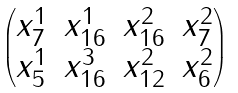<formula> <loc_0><loc_0><loc_500><loc_500>\begin{pmatrix} x _ { 7 } ^ { 1 } & x _ { 1 6 } ^ { 1 } & x _ { 1 6 } ^ { 2 } & x _ { 7 } ^ { 2 } \\ x _ { 5 } ^ { 1 } & x _ { 1 6 } ^ { 3 } & x _ { 1 2 } ^ { 2 } & x _ { 6 } ^ { 2 } \end{pmatrix}</formula> 